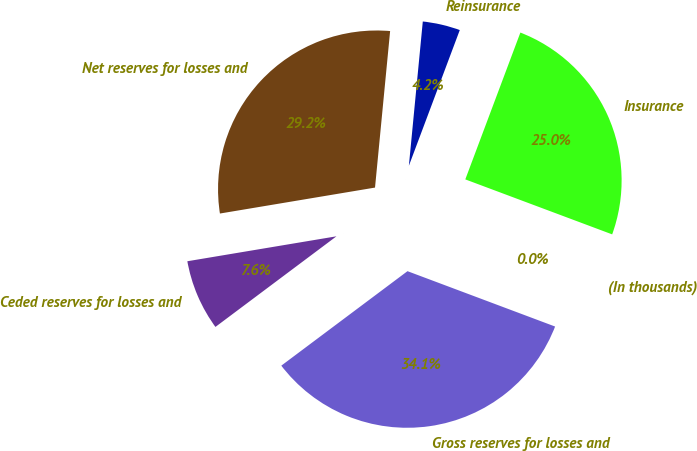<chart> <loc_0><loc_0><loc_500><loc_500><pie_chart><fcel>(In thousands)<fcel>Insurance<fcel>Reinsurance<fcel>Net reserves for losses and<fcel>Ceded reserves for losses and<fcel>Gross reserves for losses and<nl><fcel>0.01%<fcel>24.99%<fcel>4.18%<fcel>29.17%<fcel>7.59%<fcel>34.06%<nl></chart> 